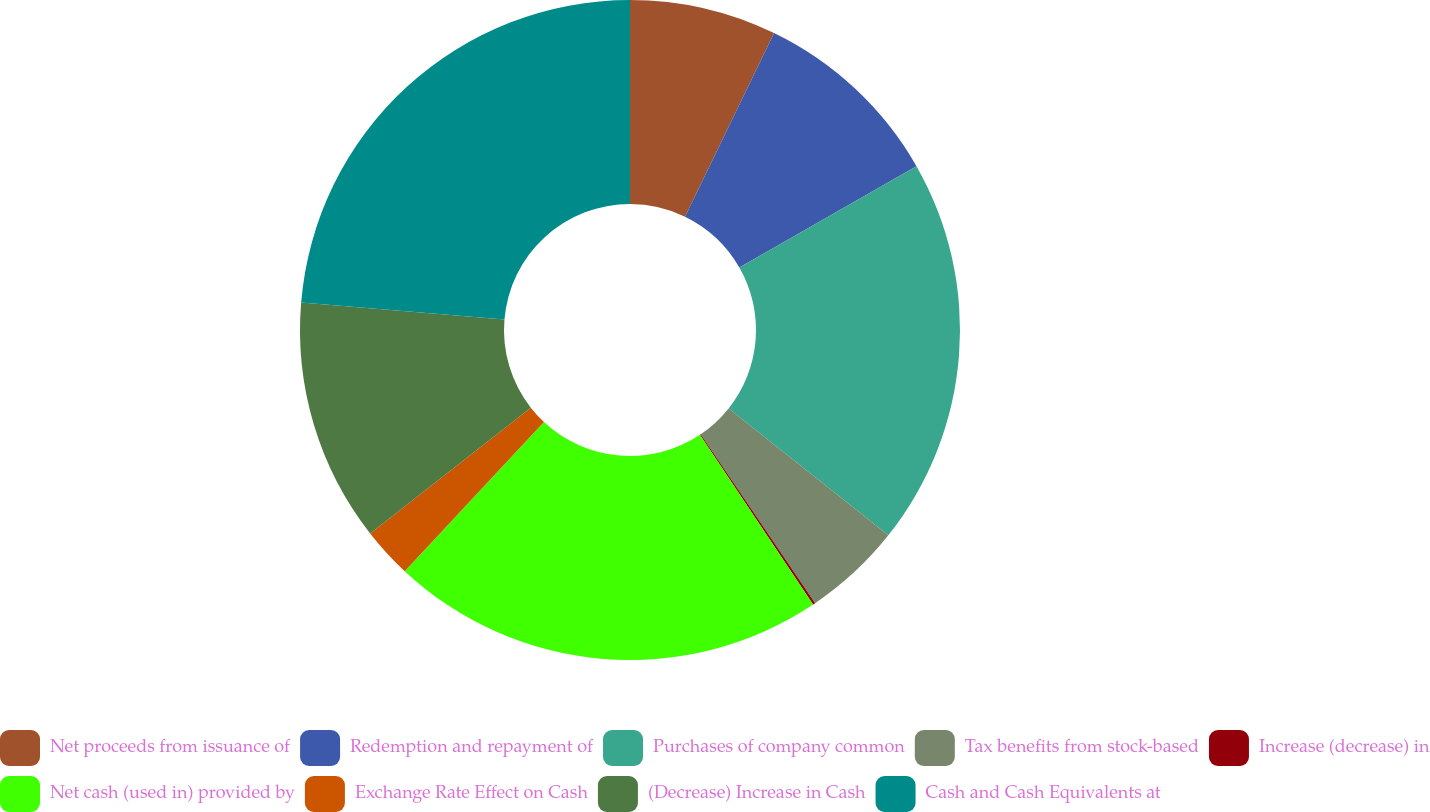Convert chart. <chart><loc_0><loc_0><loc_500><loc_500><pie_chart><fcel>Net proceeds from issuance of<fcel>Redemption and repayment of<fcel>Purchases of company common<fcel>Tax benefits from stock-based<fcel>Increase (decrease) in<fcel>Net cash (used in) provided by<fcel>Exchange Rate Effect on Cash<fcel>(Decrease) Increase in Cash<fcel>Cash and Cash Equivalents at<nl><fcel>7.19%<fcel>9.54%<fcel>18.96%<fcel>4.83%<fcel>0.12%<fcel>21.32%<fcel>2.47%<fcel>11.9%<fcel>23.67%<nl></chart> 